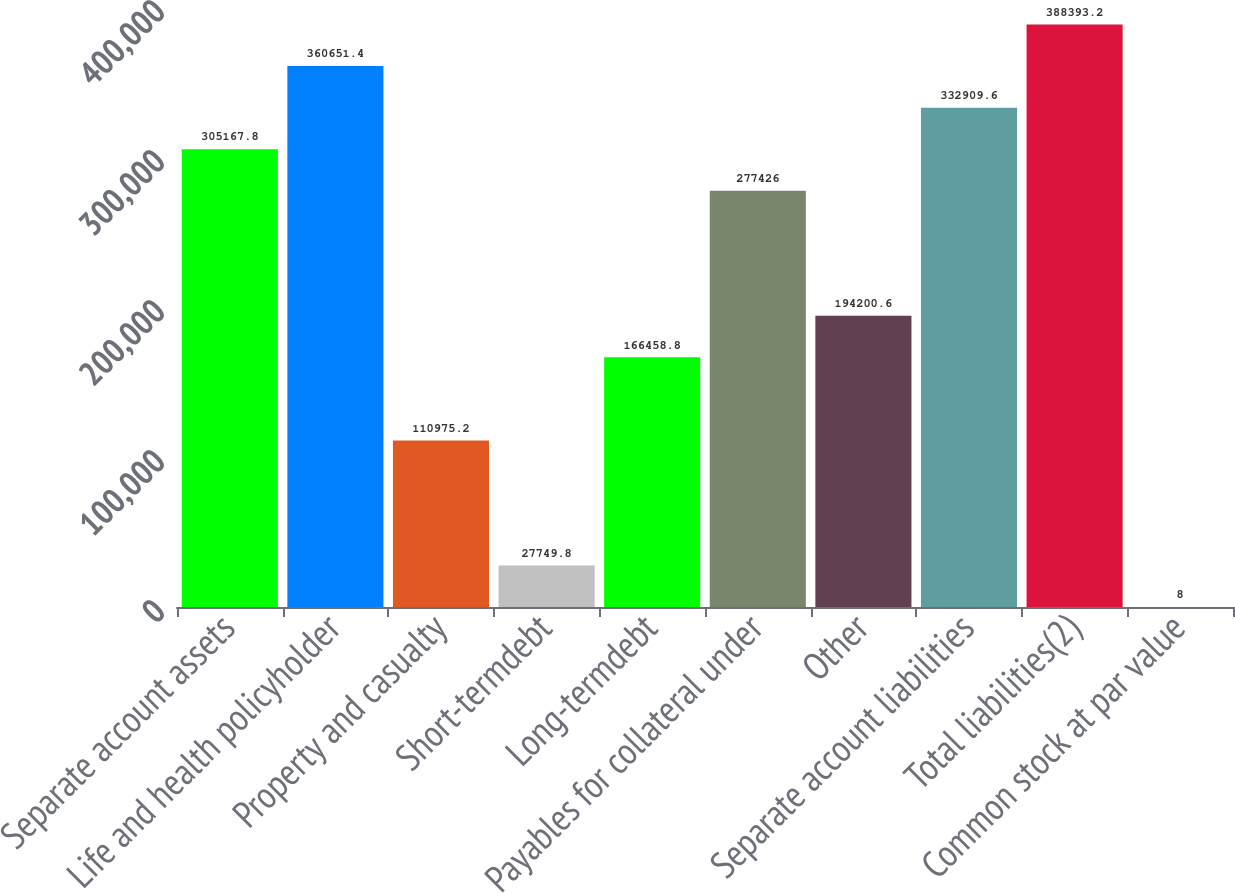<chart> <loc_0><loc_0><loc_500><loc_500><bar_chart><fcel>Separate account assets<fcel>Life and health policyholder<fcel>Property and casualty<fcel>Short-termdebt<fcel>Long-termdebt<fcel>Payables for collateral under<fcel>Other<fcel>Separate account liabilities<fcel>Total liabilities(2)<fcel>Common stock at par value<nl><fcel>305168<fcel>360651<fcel>110975<fcel>27749.8<fcel>166459<fcel>277426<fcel>194201<fcel>332910<fcel>388393<fcel>8<nl></chart> 